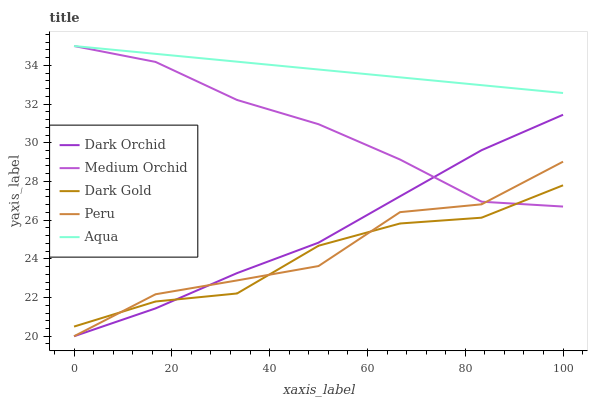Does Dark Gold have the minimum area under the curve?
Answer yes or no. Yes. Does Aqua have the maximum area under the curve?
Answer yes or no. Yes. Does Peru have the minimum area under the curve?
Answer yes or no. No. Does Peru have the maximum area under the curve?
Answer yes or no. No. Is Aqua the smoothest?
Answer yes or no. Yes. Is Peru the roughest?
Answer yes or no. Yes. Is Peru the smoothest?
Answer yes or no. No. Is Aqua the roughest?
Answer yes or no. No. Does Aqua have the lowest value?
Answer yes or no. No. Does Peru have the highest value?
Answer yes or no. No. Is Peru less than Aqua?
Answer yes or no. Yes. Is Aqua greater than Dark Gold?
Answer yes or no. Yes. Does Peru intersect Aqua?
Answer yes or no. No. 